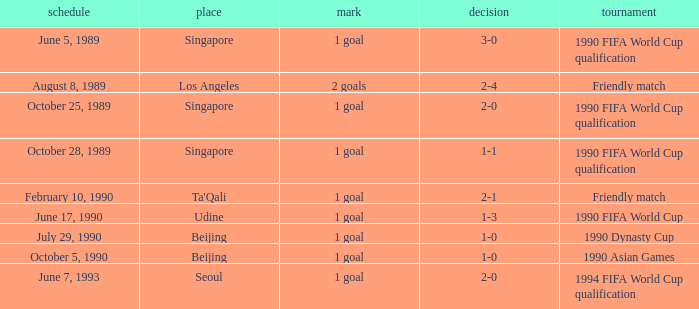What was the venue where the result was 2-1? Ta'Qali. 